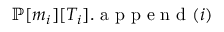<formula> <loc_0><loc_0><loc_500><loc_500>{ \mathbb { P } } [ m _ { i } ] [ T _ { i } ] . a p p e n d ( i )</formula> 